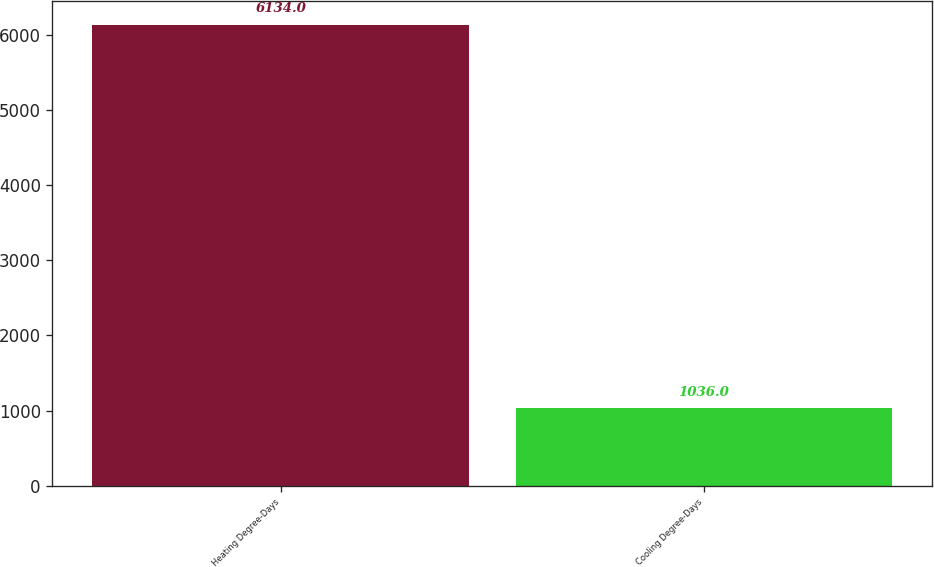<chart> <loc_0><loc_0><loc_500><loc_500><bar_chart><fcel>Heating Degree-Days<fcel>Cooling Degree-Days<nl><fcel>6134<fcel>1036<nl></chart> 